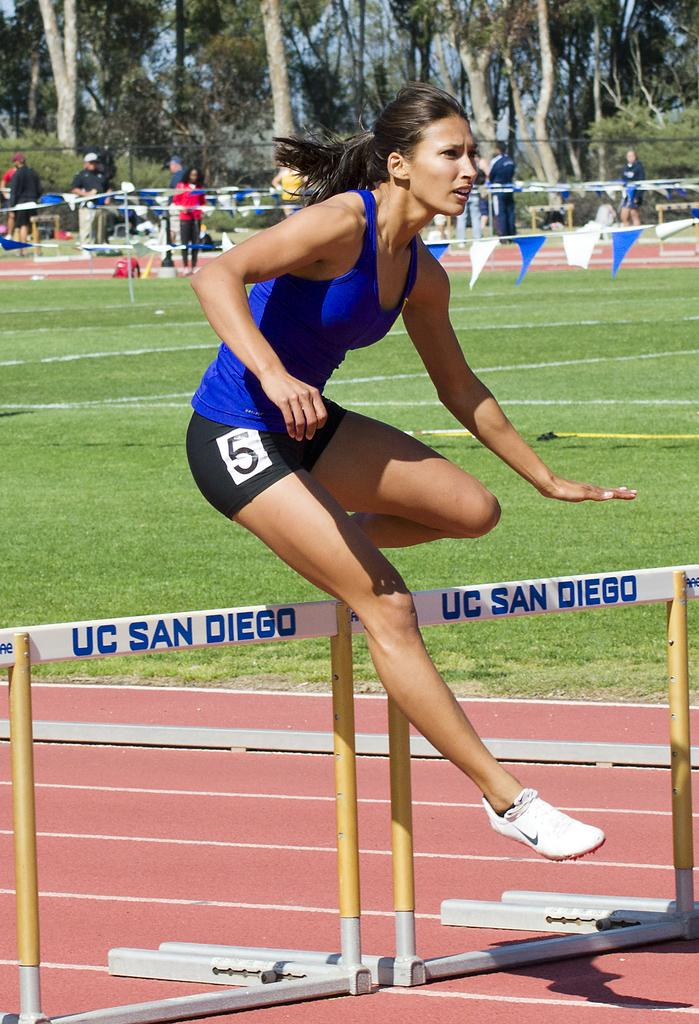Who is the main subject in the image? There is a woman in the image. What is the woman doing in the image? The woman is jumping. What type of object can be seen in the image? There is a metal object in the image. Where is the metal object located? The metal object is in a stadium. What can be seen in the background of the image? There are trees and people visible in the image. What type of blade can be seen in the woman's hand in the image? There is no blade visible in the woman's hand or anywhere else in the image. 